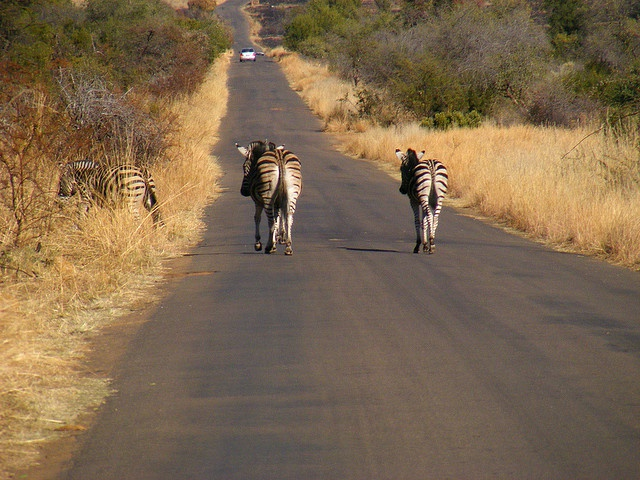Describe the objects in this image and their specific colors. I can see zebra in black, gray, maroon, and tan tones, zebra in black, tan, olive, and brown tones, zebra in black, gray, tan, and maroon tones, and car in black, white, gray, purple, and navy tones in this image. 